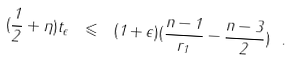Convert formula to latex. <formula><loc_0><loc_0><loc_500><loc_500>( \frac { 1 } { 2 } + \eta ) t _ { \epsilon } \ \leqslant \ ( 1 + \epsilon ) ( \frac { n - 1 } { r _ { 1 } } - \frac { n - 3 } { 2 } ) \ .</formula> 